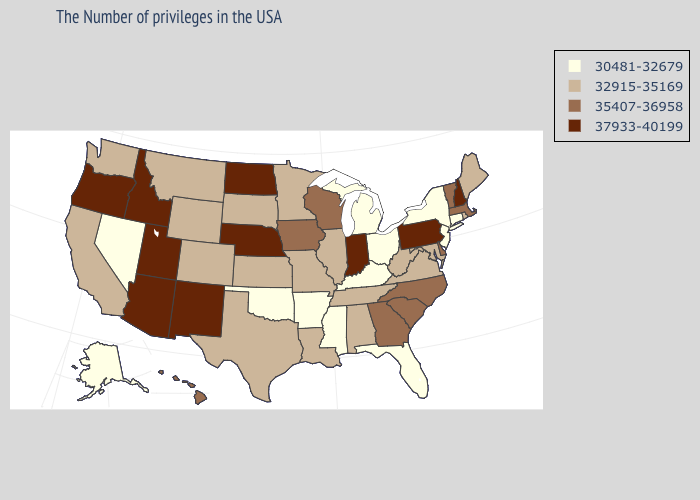Does Hawaii have the highest value in the USA?
Quick response, please. No. What is the value of Oregon?
Quick response, please. 37933-40199. Among the states that border North Carolina , does Virginia have the highest value?
Quick response, please. No. What is the highest value in states that border Washington?
Be succinct. 37933-40199. Name the states that have a value in the range 35407-36958?
Short answer required. Massachusetts, Vermont, Delaware, North Carolina, South Carolina, Georgia, Wisconsin, Iowa, Hawaii. Name the states that have a value in the range 32915-35169?
Keep it brief. Maine, Rhode Island, Maryland, Virginia, West Virginia, Alabama, Tennessee, Illinois, Louisiana, Missouri, Minnesota, Kansas, Texas, South Dakota, Wyoming, Colorado, Montana, California, Washington. Which states have the lowest value in the MidWest?
Keep it brief. Ohio, Michigan. What is the value of North Carolina?
Be succinct. 35407-36958. Among the states that border Virginia , which have the lowest value?
Quick response, please. Kentucky. What is the highest value in the MidWest ?
Give a very brief answer. 37933-40199. Which states have the lowest value in the West?
Short answer required. Nevada, Alaska. Name the states that have a value in the range 35407-36958?
Answer briefly. Massachusetts, Vermont, Delaware, North Carolina, South Carolina, Georgia, Wisconsin, Iowa, Hawaii. Does Nevada have the lowest value in the West?
Answer briefly. Yes. What is the lowest value in the Northeast?
Give a very brief answer. 30481-32679. What is the value of Maine?
Write a very short answer. 32915-35169. 